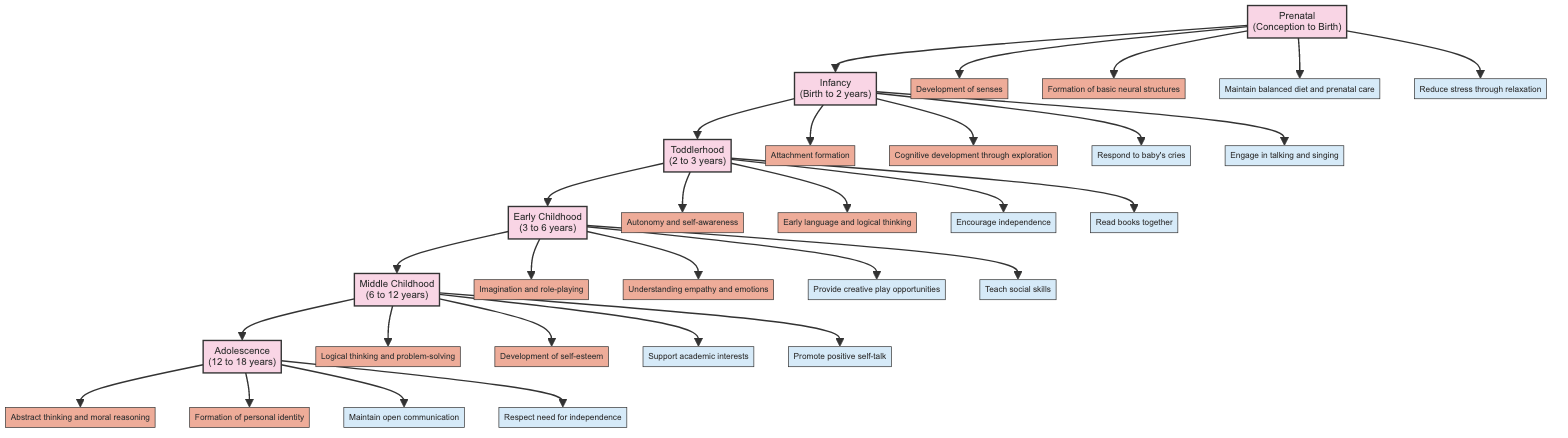What is the age range for Toddlerhood? The diagram specifies that Toddlerhood spans from 2 to 3 years. This information can be found directly associated with the node representing Toddlerhood.
Answer: 2 to 3 years How many psychological milestones are listed for Middle Childhood? To find the answer, I count the psychological milestones under the Middle Childhood stage in the diagram. There are two milestones: logical thinking and problem-solving skills, and development of self-esteem and identity.
Answer: 2 What parenting tip is associated with Early Childhood regarding play? In the Early Childhood section, there is a specific parenting tip that emphasizes providing creative play opportunities. This information can be directly retrieved from the parenting tips associated with Early Childhood.
Answer: Provide creative play opportunities Which stage has the psychological milestone of "Attachment formation"? The diagram clearly indicates that the milestone "Attachment formation" is associated with the Infancy stage. This is directly connected in the visual representation of the diagram.
Answer: Infancy What is the last psychological milestone listed for Adolescence? By reviewing the milestones listed under the Adolescence stage, I find that the last milestone mentioned is the formation of personal and social identity. This is identified at the end of the list for this stage.
Answer: Formation of personal and social identity How do parenting tips for Infancy support emotional development? The parenting tips for Infancy include responding to baby's cries to build trust and engaging in talking and singing for language development. These tips foster emotional security and language skills, which are critical for emotional development during infancy.
Answer: Build trust and promote language skills What parenting tip is repeated in different stages for fostering independence? The diagram reflects a consistent theme across different stages for fostering independence, notably in the Toddlerhood stage where it advises encouraging independence with safe choices, which resonates in the parenting tips for Adolescence regarding respecting the need for independence.
Answer: Respect need for independence Which two stages include the milestone of "Cognitive development"? Upon examining the diagram, I find that "Cognitive development" is mentioned specifically for both Infancy (through sensory exploration) and can also be interpreted under Adolescence in terms of abstract thinking. This highlights the continuity of cognitive development across these stages.
Answer: Infancy and Adolescence 